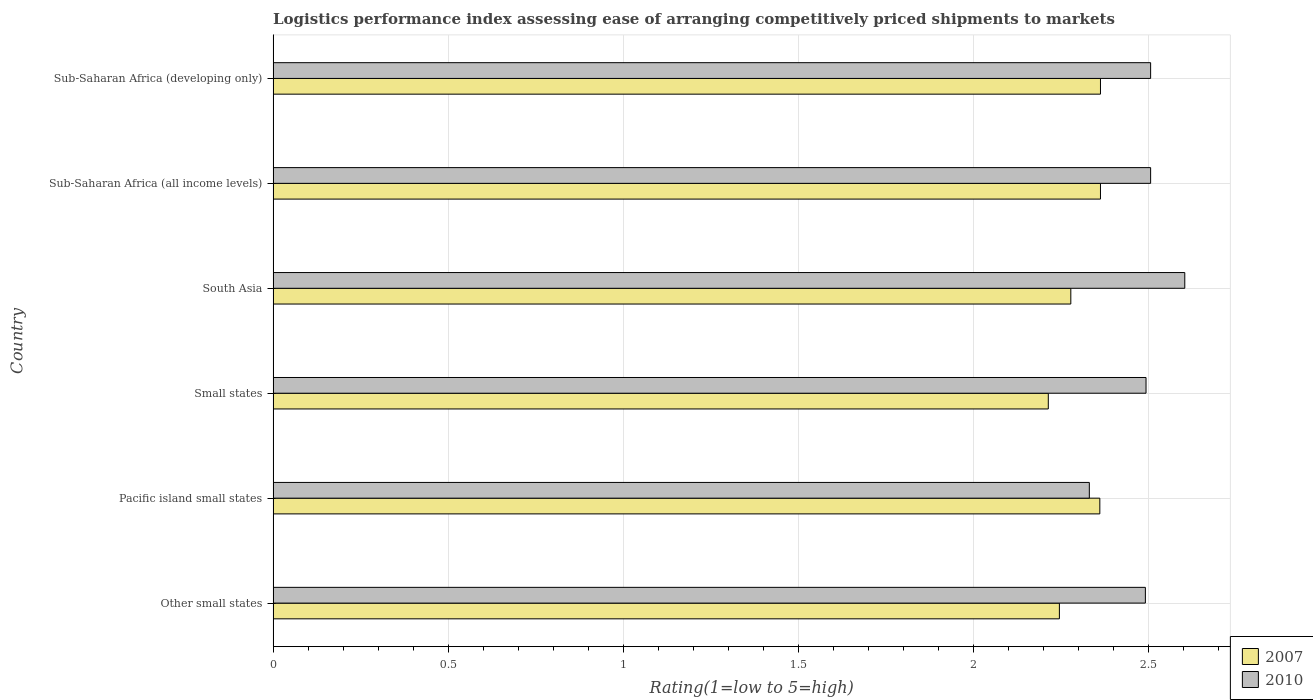Are the number of bars on each tick of the Y-axis equal?
Ensure brevity in your answer.  Yes. How many bars are there on the 3rd tick from the top?
Make the answer very short. 2. In how many cases, is the number of bars for a given country not equal to the number of legend labels?
Provide a short and direct response. 0. What is the Logistic performance index in 2007 in Other small states?
Your response must be concise. 2.24. Across all countries, what is the maximum Logistic performance index in 2010?
Your response must be concise. 2.6. Across all countries, what is the minimum Logistic performance index in 2007?
Your answer should be compact. 2.21. In which country was the Logistic performance index in 2010 maximum?
Offer a terse response. South Asia. In which country was the Logistic performance index in 2007 minimum?
Make the answer very short. Small states. What is the total Logistic performance index in 2007 in the graph?
Provide a succinct answer. 13.82. What is the difference between the Logistic performance index in 2007 in Pacific island small states and that in Small states?
Keep it short and to the point. 0.15. What is the difference between the Logistic performance index in 2007 in South Asia and the Logistic performance index in 2010 in Sub-Saharan Africa (developing only)?
Offer a very short reply. -0.23. What is the average Logistic performance index in 2010 per country?
Offer a terse response. 2.49. What is the difference between the Logistic performance index in 2007 and Logistic performance index in 2010 in Sub-Saharan Africa (all income levels)?
Give a very brief answer. -0.14. What is the ratio of the Logistic performance index in 2007 in Pacific island small states to that in Small states?
Provide a succinct answer. 1.07. Is the Logistic performance index in 2007 in Sub-Saharan Africa (all income levels) less than that in Sub-Saharan Africa (developing only)?
Provide a short and direct response. No. Is the difference between the Logistic performance index in 2007 in Pacific island small states and South Asia greater than the difference between the Logistic performance index in 2010 in Pacific island small states and South Asia?
Your answer should be very brief. Yes. What is the difference between the highest and the lowest Logistic performance index in 2007?
Offer a very short reply. 0.15. In how many countries, is the Logistic performance index in 2007 greater than the average Logistic performance index in 2007 taken over all countries?
Give a very brief answer. 3. What does the 2nd bar from the top in Pacific island small states represents?
Keep it short and to the point. 2007. Are all the bars in the graph horizontal?
Provide a short and direct response. Yes. How many countries are there in the graph?
Your answer should be very brief. 6. What is the difference between two consecutive major ticks on the X-axis?
Offer a terse response. 0.5. Does the graph contain grids?
Your answer should be compact. Yes. How many legend labels are there?
Offer a terse response. 2. What is the title of the graph?
Make the answer very short. Logistics performance index assessing ease of arranging competitively priced shipments to markets. Does "1970" appear as one of the legend labels in the graph?
Your answer should be very brief. No. What is the label or title of the X-axis?
Offer a very short reply. Rating(1=low to 5=high). What is the label or title of the Y-axis?
Give a very brief answer. Country. What is the Rating(1=low to 5=high) of 2007 in Other small states?
Provide a succinct answer. 2.24. What is the Rating(1=low to 5=high) of 2010 in Other small states?
Ensure brevity in your answer.  2.49. What is the Rating(1=low to 5=high) of 2007 in Pacific island small states?
Provide a short and direct response. 2.36. What is the Rating(1=low to 5=high) of 2010 in Pacific island small states?
Provide a succinct answer. 2.33. What is the Rating(1=low to 5=high) in 2007 in Small states?
Provide a short and direct response. 2.21. What is the Rating(1=low to 5=high) in 2010 in Small states?
Offer a very short reply. 2.49. What is the Rating(1=low to 5=high) in 2007 in South Asia?
Provide a succinct answer. 2.28. What is the Rating(1=low to 5=high) in 2010 in South Asia?
Keep it short and to the point. 2.6. What is the Rating(1=low to 5=high) in 2007 in Sub-Saharan Africa (all income levels)?
Offer a terse response. 2.36. What is the Rating(1=low to 5=high) in 2010 in Sub-Saharan Africa (all income levels)?
Ensure brevity in your answer.  2.5. What is the Rating(1=low to 5=high) in 2007 in Sub-Saharan Africa (developing only)?
Provide a short and direct response. 2.36. What is the Rating(1=low to 5=high) of 2010 in Sub-Saharan Africa (developing only)?
Your answer should be compact. 2.5. Across all countries, what is the maximum Rating(1=low to 5=high) in 2007?
Ensure brevity in your answer.  2.36. Across all countries, what is the maximum Rating(1=low to 5=high) of 2010?
Offer a very short reply. 2.6. Across all countries, what is the minimum Rating(1=low to 5=high) of 2007?
Give a very brief answer. 2.21. Across all countries, what is the minimum Rating(1=low to 5=high) in 2010?
Ensure brevity in your answer.  2.33. What is the total Rating(1=low to 5=high) of 2007 in the graph?
Offer a very short reply. 13.82. What is the total Rating(1=low to 5=high) of 2010 in the graph?
Offer a very short reply. 14.92. What is the difference between the Rating(1=low to 5=high) of 2007 in Other small states and that in Pacific island small states?
Your answer should be very brief. -0.12. What is the difference between the Rating(1=low to 5=high) of 2010 in Other small states and that in Pacific island small states?
Give a very brief answer. 0.16. What is the difference between the Rating(1=low to 5=high) in 2007 in Other small states and that in Small states?
Ensure brevity in your answer.  0.03. What is the difference between the Rating(1=low to 5=high) of 2010 in Other small states and that in Small states?
Offer a very short reply. -0. What is the difference between the Rating(1=low to 5=high) in 2007 in Other small states and that in South Asia?
Ensure brevity in your answer.  -0.03. What is the difference between the Rating(1=low to 5=high) in 2010 in Other small states and that in South Asia?
Offer a very short reply. -0.11. What is the difference between the Rating(1=low to 5=high) of 2007 in Other small states and that in Sub-Saharan Africa (all income levels)?
Your answer should be compact. -0.12. What is the difference between the Rating(1=low to 5=high) of 2010 in Other small states and that in Sub-Saharan Africa (all income levels)?
Your answer should be compact. -0.01. What is the difference between the Rating(1=low to 5=high) of 2007 in Other small states and that in Sub-Saharan Africa (developing only)?
Keep it short and to the point. -0.12. What is the difference between the Rating(1=low to 5=high) of 2010 in Other small states and that in Sub-Saharan Africa (developing only)?
Provide a short and direct response. -0.01. What is the difference between the Rating(1=low to 5=high) in 2007 in Pacific island small states and that in Small states?
Your response must be concise. 0.15. What is the difference between the Rating(1=low to 5=high) of 2010 in Pacific island small states and that in Small states?
Ensure brevity in your answer.  -0.16. What is the difference between the Rating(1=low to 5=high) of 2007 in Pacific island small states and that in South Asia?
Offer a very short reply. 0.08. What is the difference between the Rating(1=low to 5=high) of 2010 in Pacific island small states and that in South Asia?
Offer a very short reply. -0.27. What is the difference between the Rating(1=low to 5=high) of 2007 in Pacific island small states and that in Sub-Saharan Africa (all income levels)?
Give a very brief answer. -0. What is the difference between the Rating(1=low to 5=high) in 2010 in Pacific island small states and that in Sub-Saharan Africa (all income levels)?
Offer a terse response. -0.17. What is the difference between the Rating(1=low to 5=high) in 2007 in Pacific island small states and that in Sub-Saharan Africa (developing only)?
Keep it short and to the point. -0. What is the difference between the Rating(1=low to 5=high) of 2010 in Pacific island small states and that in Sub-Saharan Africa (developing only)?
Provide a short and direct response. -0.17. What is the difference between the Rating(1=low to 5=high) of 2007 in Small states and that in South Asia?
Ensure brevity in your answer.  -0.06. What is the difference between the Rating(1=low to 5=high) of 2010 in Small states and that in South Asia?
Provide a succinct answer. -0.11. What is the difference between the Rating(1=low to 5=high) in 2007 in Small states and that in Sub-Saharan Africa (all income levels)?
Provide a short and direct response. -0.15. What is the difference between the Rating(1=low to 5=high) in 2010 in Small states and that in Sub-Saharan Africa (all income levels)?
Provide a succinct answer. -0.01. What is the difference between the Rating(1=low to 5=high) of 2007 in Small states and that in Sub-Saharan Africa (developing only)?
Make the answer very short. -0.15. What is the difference between the Rating(1=low to 5=high) of 2010 in Small states and that in Sub-Saharan Africa (developing only)?
Your answer should be compact. -0.01. What is the difference between the Rating(1=low to 5=high) of 2007 in South Asia and that in Sub-Saharan Africa (all income levels)?
Offer a very short reply. -0.08. What is the difference between the Rating(1=low to 5=high) in 2010 in South Asia and that in Sub-Saharan Africa (all income levels)?
Give a very brief answer. 0.1. What is the difference between the Rating(1=low to 5=high) of 2007 in South Asia and that in Sub-Saharan Africa (developing only)?
Provide a short and direct response. -0.08. What is the difference between the Rating(1=low to 5=high) in 2010 in South Asia and that in Sub-Saharan Africa (developing only)?
Provide a short and direct response. 0.1. What is the difference between the Rating(1=low to 5=high) in 2007 in Sub-Saharan Africa (all income levels) and that in Sub-Saharan Africa (developing only)?
Your answer should be very brief. 0. What is the difference between the Rating(1=low to 5=high) in 2007 in Other small states and the Rating(1=low to 5=high) in 2010 in Pacific island small states?
Your answer should be compact. -0.09. What is the difference between the Rating(1=low to 5=high) in 2007 in Other small states and the Rating(1=low to 5=high) in 2010 in Small states?
Offer a very short reply. -0.25. What is the difference between the Rating(1=low to 5=high) of 2007 in Other small states and the Rating(1=low to 5=high) of 2010 in South Asia?
Make the answer very short. -0.36. What is the difference between the Rating(1=low to 5=high) of 2007 in Other small states and the Rating(1=low to 5=high) of 2010 in Sub-Saharan Africa (all income levels)?
Your answer should be compact. -0.26. What is the difference between the Rating(1=low to 5=high) of 2007 in Other small states and the Rating(1=low to 5=high) of 2010 in Sub-Saharan Africa (developing only)?
Your answer should be very brief. -0.26. What is the difference between the Rating(1=low to 5=high) in 2007 in Pacific island small states and the Rating(1=low to 5=high) in 2010 in Small states?
Your answer should be very brief. -0.13. What is the difference between the Rating(1=low to 5=high) of 2007 in Pacific island small states and the Rating(1=low to 5=high) of 2010 in South Asia?
Your answer should be very brief. -0.24. What is the difference between the Rating(1=low to 5=high) of 2007 in Pacific island small states and the Rating(1=low to 5=high) of 2010 in Sub-Saharan Africa (all income levels)?
Your answer should be very brief. -0.14. What is the difference between the Rating(1=low to 5=high) of 2007 in Pacific island small states and the Rating(1=low to 5=high) of 2010 in Sub-Saharan Africa (developing only)?
Keep it short and to the point. -0.14. What is the difference between the Rating(1=low to 5=high) in 2007 in Small states and the Rating(1=low to 5=high) in 2010 in South Asia?
Give a very brief answer. -0.39. What is the difference between the Rating(1=low to 5=high) of 2007 in Small states and the Rating(1=low to 5=high) of 2010 in Sub-Saharan Africa (all income levels)?
Make the answer very short. -0.29. What is the difference between the Rating(1=low to 5=high) in 2007 in Small states and the Rating(1=low to 5=high) in 2010 in Sub-Saharan Africa (developing only)?
Offer a terse response. -0.29. What is the difference between the Rating(1=low to 5=high) of 2007 in South Asia and the Rating(1=low to 5=high) of 2010 in Sub-Saharan Africa (all income levels)?
Your answer should be compact. -0.23. What is the difference between the Rating(1=low to 5=high) of 2007 in South Asia and the Rating(1=low to 5=high) of 2010 in Sub-Saharan Africa (developing only)?
Provide a succinct answer. -0.23. What is the difference between the Rating(1=low to 5=high) in 2007 in Sub-Saharan Africa (all income levels) and the Rating(1=low to 5=high) in 2010 in Sub-Saharan Africa (developing only)?
Offer a terse response. -0.14. What is the average Rating(1=low to 5=high) in 2007 per country?
Offer a terse response. 2.3. What is the average Rating(1=low to 5=high) of 2010 per country?
Make the answer very short. 2.49. What is the difference between the Rating(1=low to 5=high) in 2007 and Rating(1=low to 5=high) in 2010 in Other small states?
Offer a terse response. -0.25. What is the difference between the Rating(1=low to 5=high) in 2007 and Rating(1=low to 5=high) in 2010 in Small states?
Offer a very short reply. -0.28. What is the difference between the Rating(1=low to 5=high) of 2007 and Rating(1=low to 5=high) of 2010 in South Asia?
Ensure brevity in your answer.  -0.33. What is the difference between the Rating(1=low to 5=high) of 2007 and Rating(1=low to 5=high) of 2010 in Sub-Saharan Africa (all income levels)?
Your answer should be compact. -0.14. What is the difference between the Rating(1=low to 5=high) of 2007 and Rating(1=low to 5=high) of 2010 in Sub-Saharan Africa (developing only)?
Provide a short and direct response. -0.14. What is the ratio of the Rating(1=low to 5=high) of 2007 in Other small states to that in Pacific island small states?
Ensure brevity in your answer.  0.95. What is the ratio of the Rating(1=low to 5=high) in 2010 in Other small states to that in Pacific island small states?
Provide a short and direct response. 1.07. What is the ratio of the Rating(1=low to 5=high) of 2007 in Other small states to that in Small states?
Make the answer very short. 1.01. What is the ratio of the Rating(1=low to 5=high) of 2007 in Other small states to that in South Asia?
Your answer should be compact. 0.99. What is the ratio of the Rating(1=low to 5=high) in 2010 in Other small states to that in South Asia?
Your answer should be compact. 0.96. What is the ratio of the Rating(1=low to 5=high) of 2007 in Other small states to that in Sub-Saharan Africa (all income levels)?
Your response must be concise. 0.95. What is the ratio of the Rating(1=low to 5=high) of 2007 in Other small states to that in Sub-Saharan Africa (developing only)?
Provide a short and direct response. 0.95. What is the ratio of the Rating(1=low to 5=high) of 2007 in Pacific island small states to that in Small states?
Provide a succinct answer. 1.07. What is the ratio of the Rating(1=low to 5=high) of 2010 in Pacific island small states to that in Small states?
Provide a short and direct response. 0.94. What is the ratio of the Rating(1=low to 5=high) in 2007 in Pacific island small states to that in South Asia?
Make the answer very short. 1.04. What is the ratio of the Rating(1=low to 5=high) in 2010 in Pacific island small states to that in South Asia?
Offer a very short reply. 0.9. What is the ratio of the Rating(1=low to 5=high) in 2007 in Pacific island small states to that in Sub-Saharan Africa (all income levels)?
Give a very brief answer. 1. What is the ratio of the Rating(1=low to 5=high) of 2010 in Pacific island small states to that in Sub-Saharan Africa (all income levels)?
Keep it short and to the point. 0.93. What is the ratio of the Rating(1=low to 5=high) of 2010 in Pacific island small states to that in Sub-Saharan Africa (developing only)?
Offer a terse response. 0.93. What is the ratio of the Rating(1=low to 5=high) in 2007 in Small states to that in South Asia?
Give a very brief answer. 0.97. What is the ratio of the Rating(1=low to 5=high) of 2010 in Small states to that in South Asia?
Your response must be concise. 0.96. What is the ratio of the Rating(1=low to 5=high) in 2007 in Small states to that in Sub-Saharan Africa (all income levels)?
Make the answer very short. 0.94. What is the ratio of the Rating(1=low to 5=high) in 2007 in Small states to that in Sub-Saharan Africa (developing only)?
Ensure brevity in your answer.  0.94. What is the ratio of the Rating(1=low to 5=high) of 2010 in Small states to that in Sub-Saharan Africa (developing only)?
Your answer should be very brief. 0.99. What is the ratio of the Rating(1=low to 5=high) of 2007 in South Asia to that in Sub-Saharan Africa (all income levels)?
Provide a short and direct response. 0.96. What is the ratio of the Rating(1=low to 5=high) in 2010 in South Asia to that in Sub-Saharan Africa (all income levels)?
Offer a very short reply. 1.04. What is the ratio of the Rating(1=low to 5=high) of 2007 in South Asia to that in Sub-Saharan Africa (developing only)?
Provide a succinct answer. 0.96. What is the ratio of the Rating(1=low to 5=high) in 2010 in South Asia to that in Sub-Saharan Africa (developing only)?
Offer a terse response. 1.04. What is the difference between the highest and the second highest Rating(1=low to 5=high) of 2007?
Keep it short and to the point. 0. What is the difference between the highest and the second highest Rating(1=low to 5=high) of 2010?
Keep it short and to the point. 0.1. What is the difference between the highest and the lowest Rating(1=low to 5=high) in 2007?
Offer a terse response. 0.15. What is the difference between the highest and the lowest Rating(1=low to 5=high) of 2010?
Give a very brief answer. 0.27. 